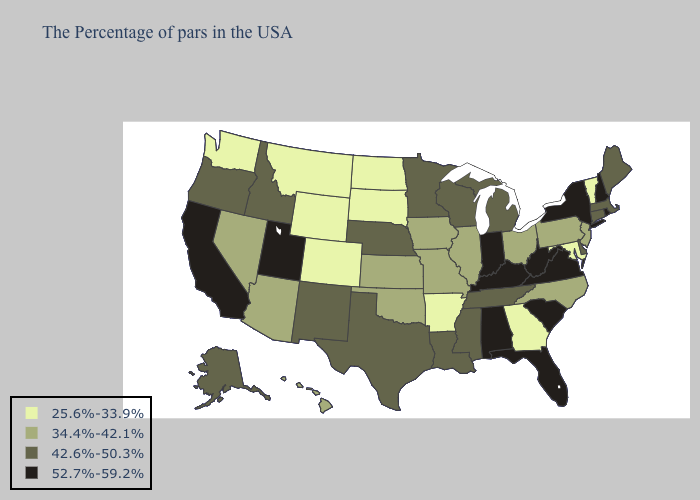Among the states that border Colorado , does Wyoming have the lowest value?
Keep it brief. Yes. Does South Dakota have the lowest value in the USA?
Quick response, please. Yes. What is the highest value in the West ?
Keep it brief. 52.7%-59.2%. Does Colorado have the same value as West Virginia?
Keep it brief. No. What is the value of Connecticut?
Quick response, please. 42.6%-50.3%. What is the highest value in states that border Rhode Island?
Short answer required. 42.6%-50.3%. Which states have the highest value in the USA?
Quick response, please. Rhode Island, New Hampshire, New York, Virginia, South Carolina, West Virginia, Florida, Kentucky, Indiana, Alabama, Utah, California. Name the states that have a value in the range 25.6%-33.9%?
Answer briefly. Vermont, Maryland, Georgia, Arkansas, South Dakota, North Dakota, Wyoming, Colorado, Montana, Washington. What is the highest value in the Northeast ?
Quick response, please. 52.7%-59.2%. Which states hav the highest value in the West?
Quick response, please. Utah, California. What is the lowest value in the MidWest?
Answer briefly. 25.6%-33.9%. What is the value of Mississippi?
Short answer required. 42.6%-50.3%. What is the value of Washington?
Write a very short answer. 25.6%-33.9%. Does Mississippi have a higher value than Pennsylvania?
Concise answer only. Yes. Name the states that have a value in the range 42.6%-50.3%?
Concise answer only. Maine, Massachusetts, Connecticut, Delaware, Michigan, Tennessee, Wisconsin, Mississippi, Louisiana, Minnesota, Nebraska, Texas, New Mexico, Idaho, Oregon, Alaska. 